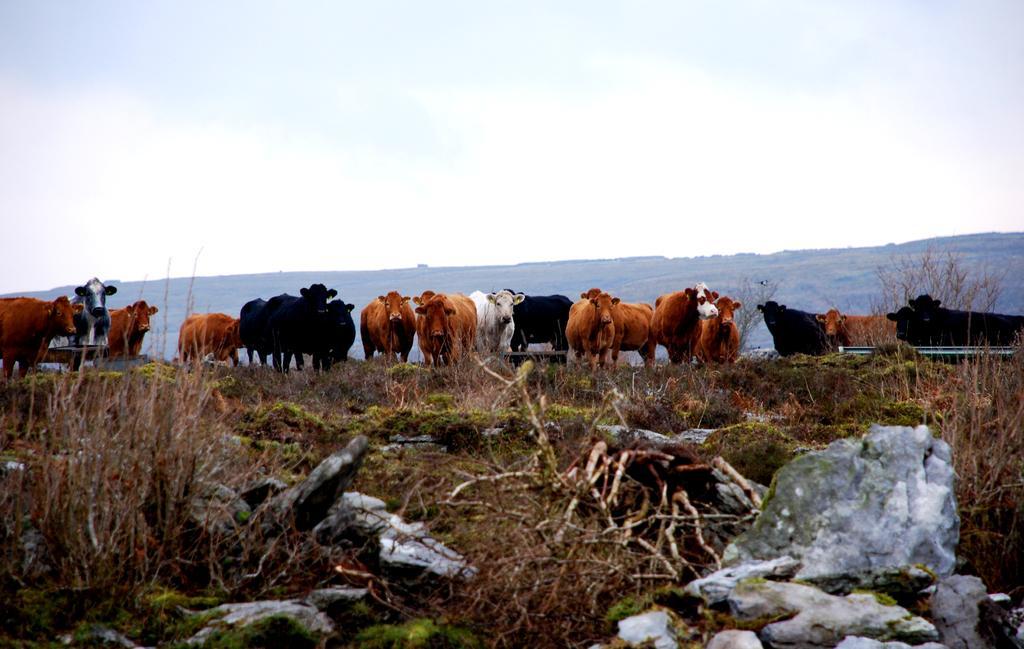In one or two sentences, can you explain what this image depicts? In this picture we can see there are branches, rocks and a herd of animals. Behind the animals there is a hill and the sky. 